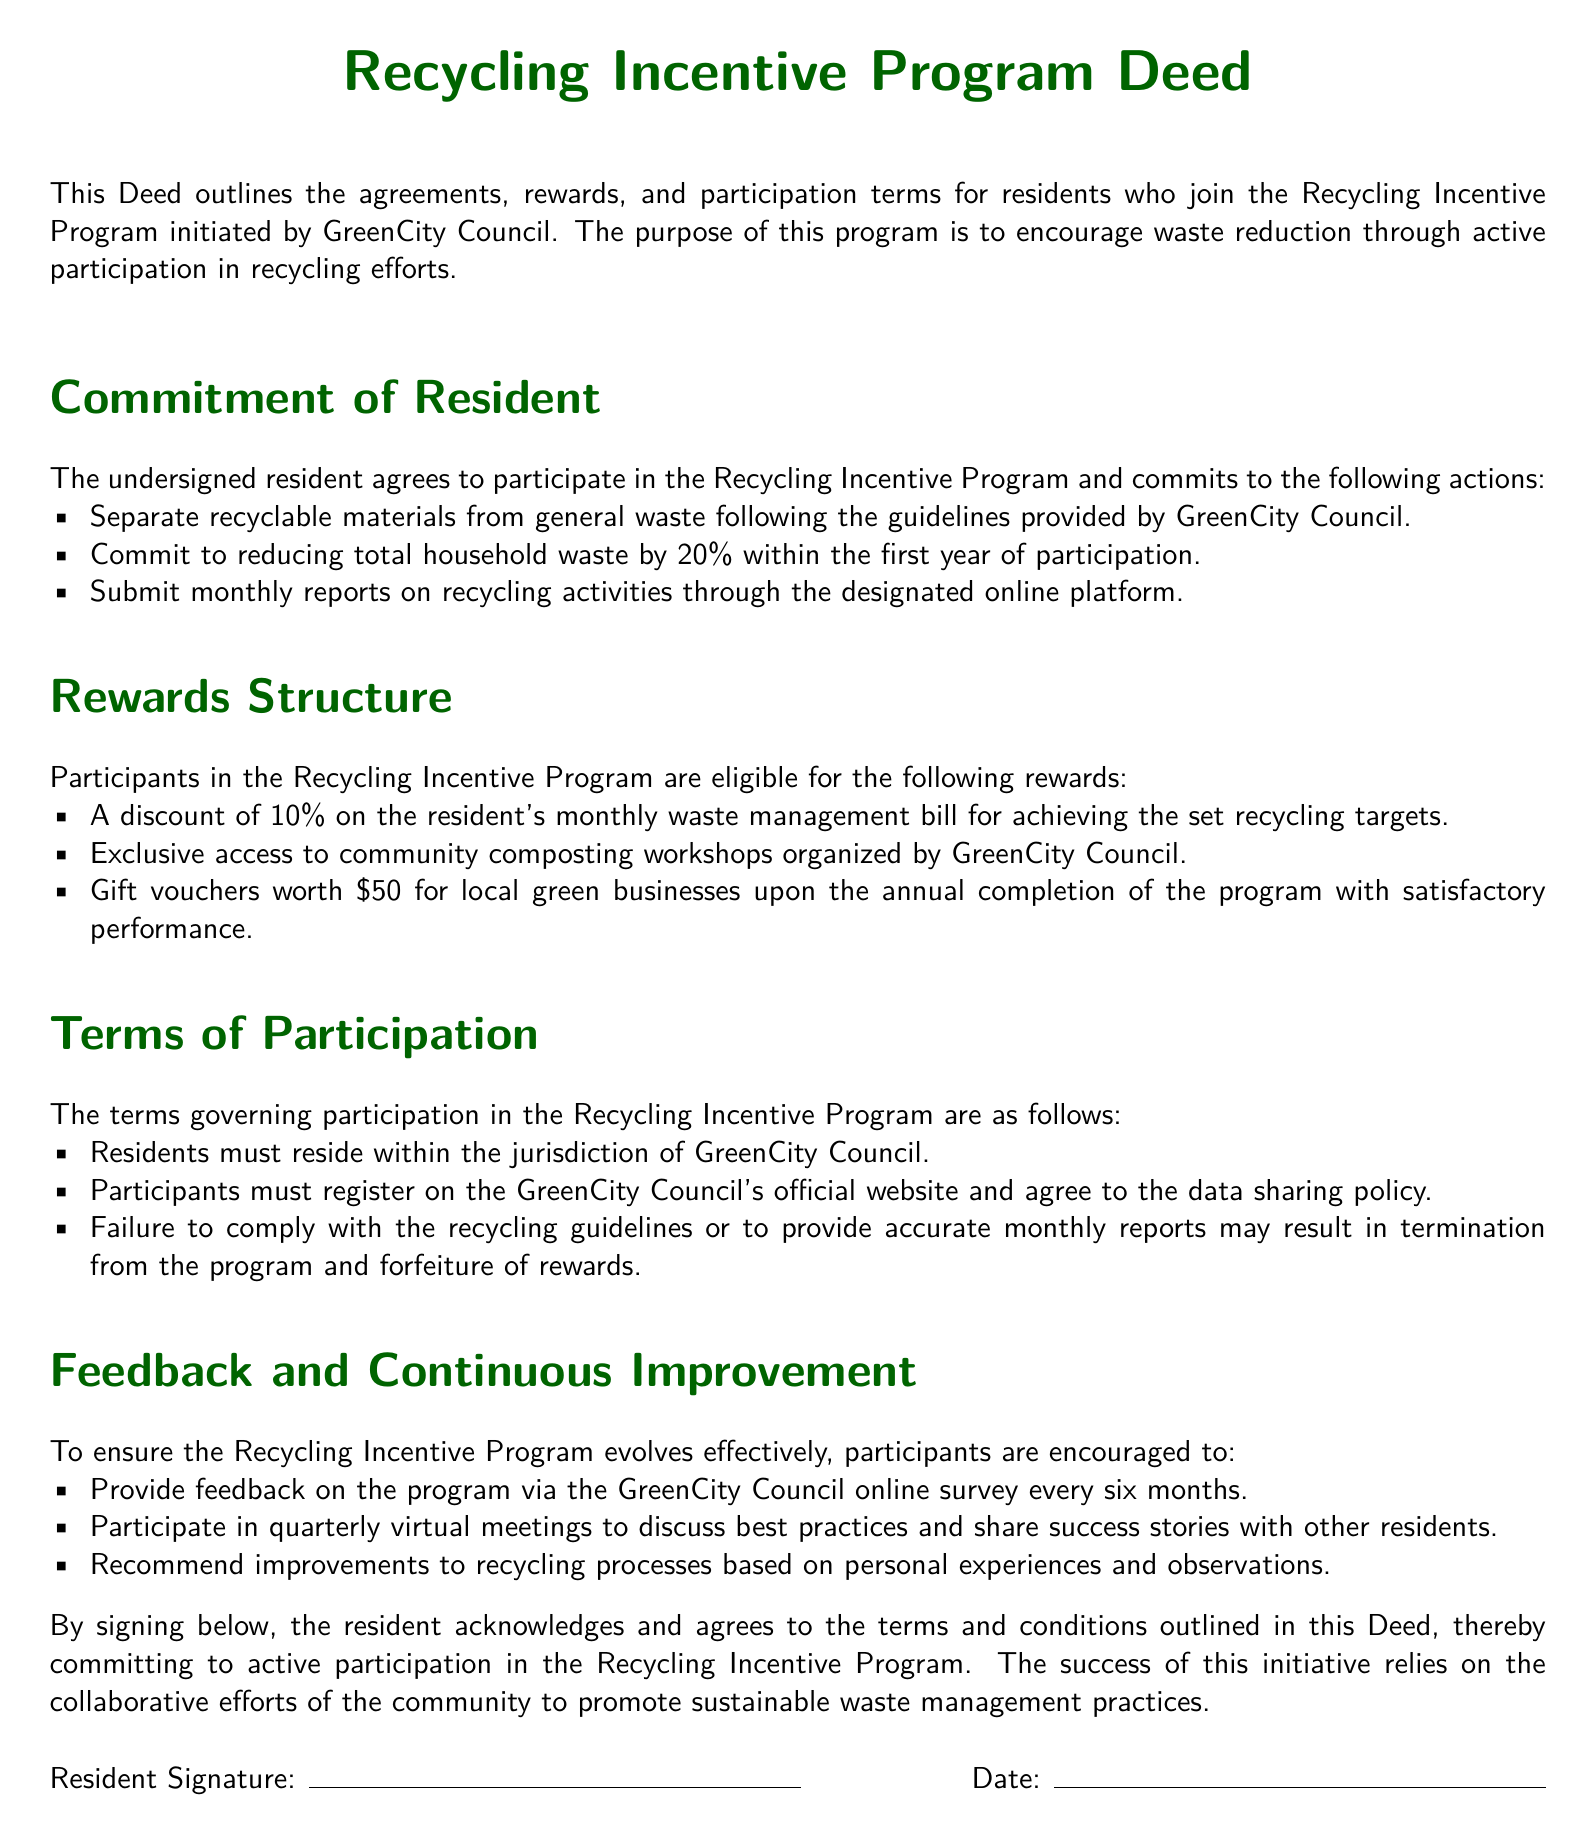What is the discount on the waste management bill for achieving recycling targets? The discount is specified in the rewards structure, indicating a percentage off the resident's monthly waste management bill for reaching targets.
Answer: 10% What is the commitment required from residents regarding waste reduction in the first year? This commitment is found in the "Commitment of Resident" section, detailing the specific reduction percentage that residents must achieve.
Answer: 20% What should residents submit monthly? This information is stated in the "Commitment of Resident" section, outlining what residents are expected to report monthly.
Answer: Reports on recycling activities What is one of the rewards for participating in the program for a year? This is included in the "Rewards Structure" section, highlighting a specific incentive for long-term participants achieving satisfactory performance.
Answer: Gift vouchers worth 50 dollars What do residents need to do to participate in the program? This requirement can be found in the "Terms of Participation" section, stating the necessary action for residents to officially join the program.
Answer: Register on the GreenCity Council's official website What types of feedback are participants encouraged to provide? This information is located in the "Feedback and Continuous Improvement" section, indicating the forms of feedback that can be shared by residents for program enhancement.
Answer: Feedback via the online survey Under which jurisdiction must residents reside to join the program? This is outlined in the "Terms of Participation" and specifies the governing body relevant to the program.
Answer: GreenCity Council What are the consequences of failing to comply with recycling guidelines? This detail is provided in the "Terms of Participation" section, regarding the repercussions of not meeting program requirements.
Answer: Termination from the program 